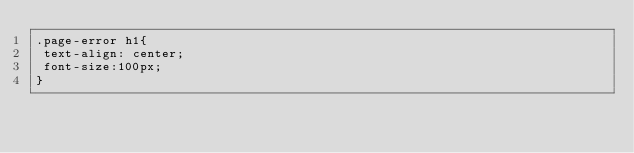<code> <loc_0><loc_0><loc_500><loc_500><_CSS_>.page-error h1{
 text-align: center;
 font-size:100px;
}</code> 